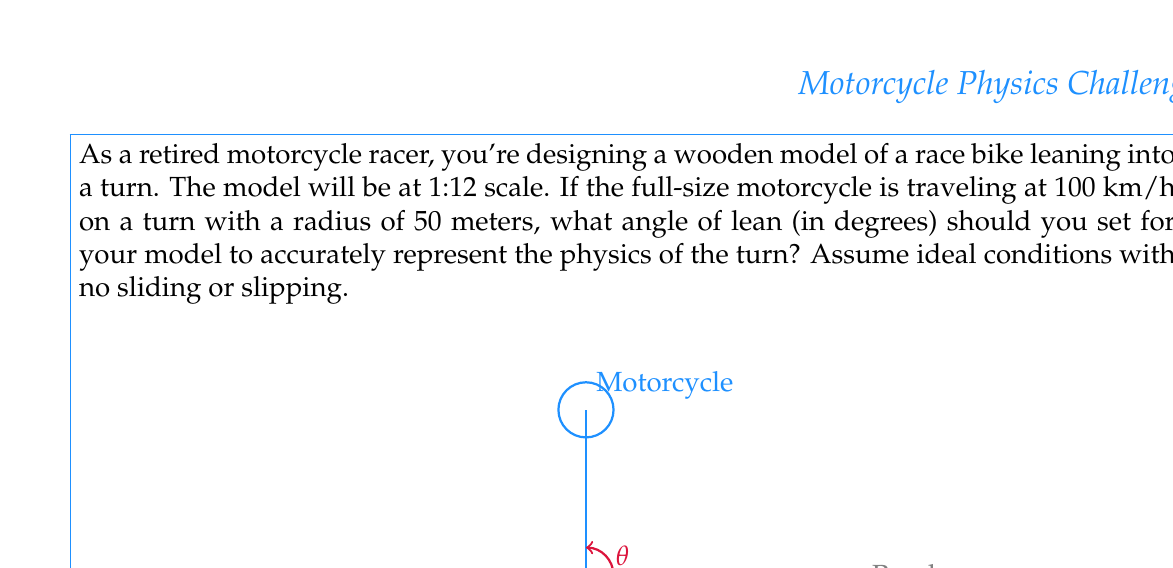Could you help me with this problem? To solve this problem, we need to use the physics of circular motion and the concept of centripetal force. Here's a step-by-step explanation:

1) The angle of lean $\theta$ is determined by the balance between gravity and the centripetal force required to keep the motorcycle on its circular path.

2) The centripetal force is given by $F_c = \frac{mv^2}{r}$, where $m$ is the mass of the motorcycle and rider, $v$ is the velocity, and $r$ is the radius of the turn.

3) The gravitational force is simply $F_g = mg$, where $g$ is the acceleration due to gravity (9.81 m/s²).

4) The angle of lean is the angle between the vertical and the line connecting the center of mass to the point of contact with the road. This angle is given by:

   $$\tan(\theta) = \frac{F_c}{F_g} = \frac{v^2}{rg}$$

5) We need to convert the given speed from km/h to m/s:
   100 km/h = 100 * 1000 / 3600 ≈ 27.78 m/s

6) Now we can plug in our values:
   $$\tan(\theta) = \frac{(27.78)^2}{50 * 9.81} \approx 1.5717$$

7) To get the angle in degrees, we need to take the inverse tangent and convert to degrees:
   $$\theta = \arctan(1.5717) * \frac{180}{\pi} \approx 57.52°$$

8) Since the model is at 1:12 scale, the angle remains the same as it would for the full-size motorcycle.

Therefore, you should set the lean angle of your wooden model to approximately 57.52°.
Answer: 57.52° 